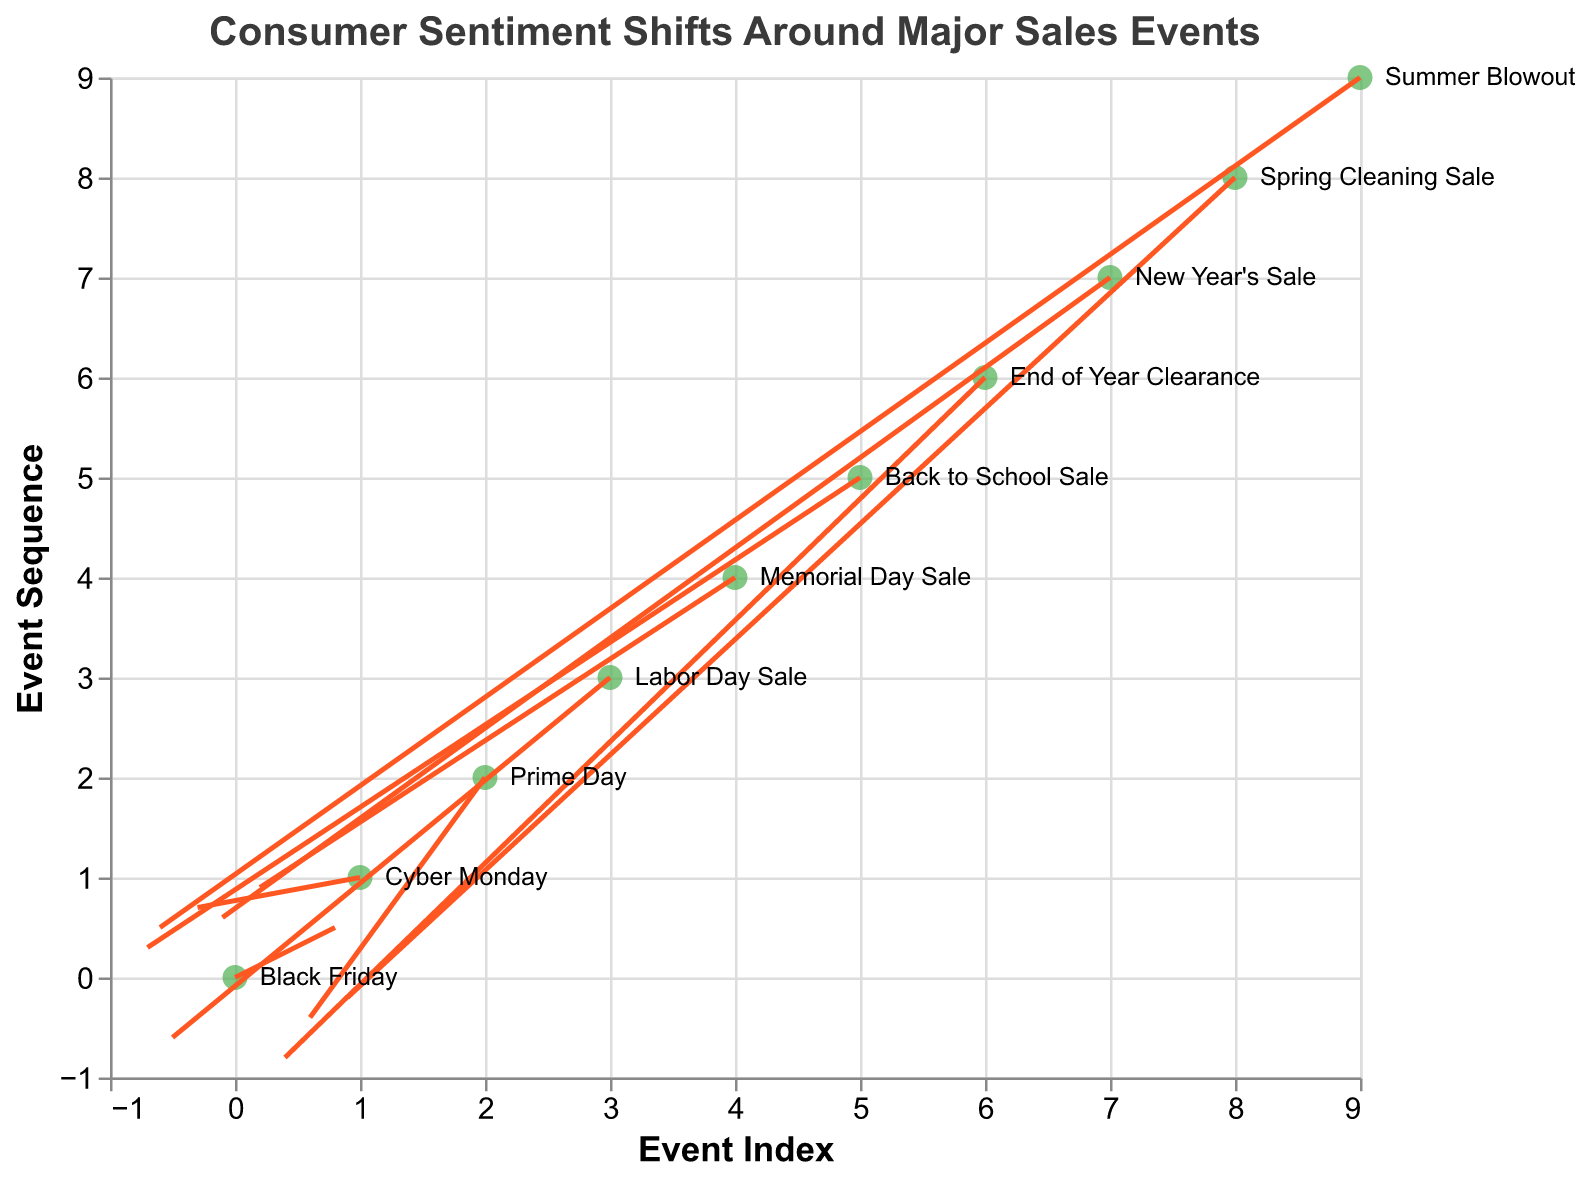How many sales events are represented in the figure? Count the number of distinct labels for sales events listed beside the plotted points in the figure.
Answer: 10 What is the overall trend in consumer sentiment for "Memorial Day Sale"? Look at the quiver vector's direction for "Memorial Day Sale"; identify the coordinates (4,4) and the vector components (0.2, 0.9). This shows an increase in sentiment along both axes.
Answer: Increasing Which sales event has a significant negative shift in consumer sentiment? Identify the vectors with significant negative components in u and v. The vector at (3, 3) for "Labor Day Sale" has negative components in both u and v (-0.5, -0.6).
Answer: Labor Day Sale What is the average change in the x-direction (u) across all sales events? Sum all the u components (0.8 - 0.3 + 0.6 - 0.5 + 0.2 - 0.7 + 0.4 - 0.1 + 0.9 - 0.6) and divide by the number of events (10).
Answer: 0.07 Which event shows the least amount of change in consumer sentiment in the y-direction? Identify the event with the smallest absolute value in the v component. "End of Year Clearance" has a v component of -0.8, which is the smallest by absolute value.
Answer: Prime Day What is the aggregated consumer sentiment shift vector (u, v) from Black Friday and Cyber Monday? Sum the vectors (0.8, 0.5) and (-0.3, 0.7) component-wise: (0.8 - 0.3, 0.5 + 0.7) resulting in (0.5, 1.2).
Answer: (0.5, 1.2) Which event shows a downward shift in consumer sentiment on both axes? Identify events where both u and v components are negative. The "Labor Day Sale" vector (-0.5, -0.6) fits this condition.
Answer: Labor Day Sale Compared to "New Year's Sale", which event shows a greater positive shift in the y-direction? Compare the v components for "New Year's Sale" (0.6) and other events, identifying any event with a larger value. "Memorial Day Sale" with v=0.9 is greater.
Answer: Memorial Day Sale What is the total number of events showing a positive shift in the x-direction? Count the number of events with a positive u component. Events include (0.8, 0.6, 0.2, 0.4, 0.9), meaning 5 events.
Answer: 5 